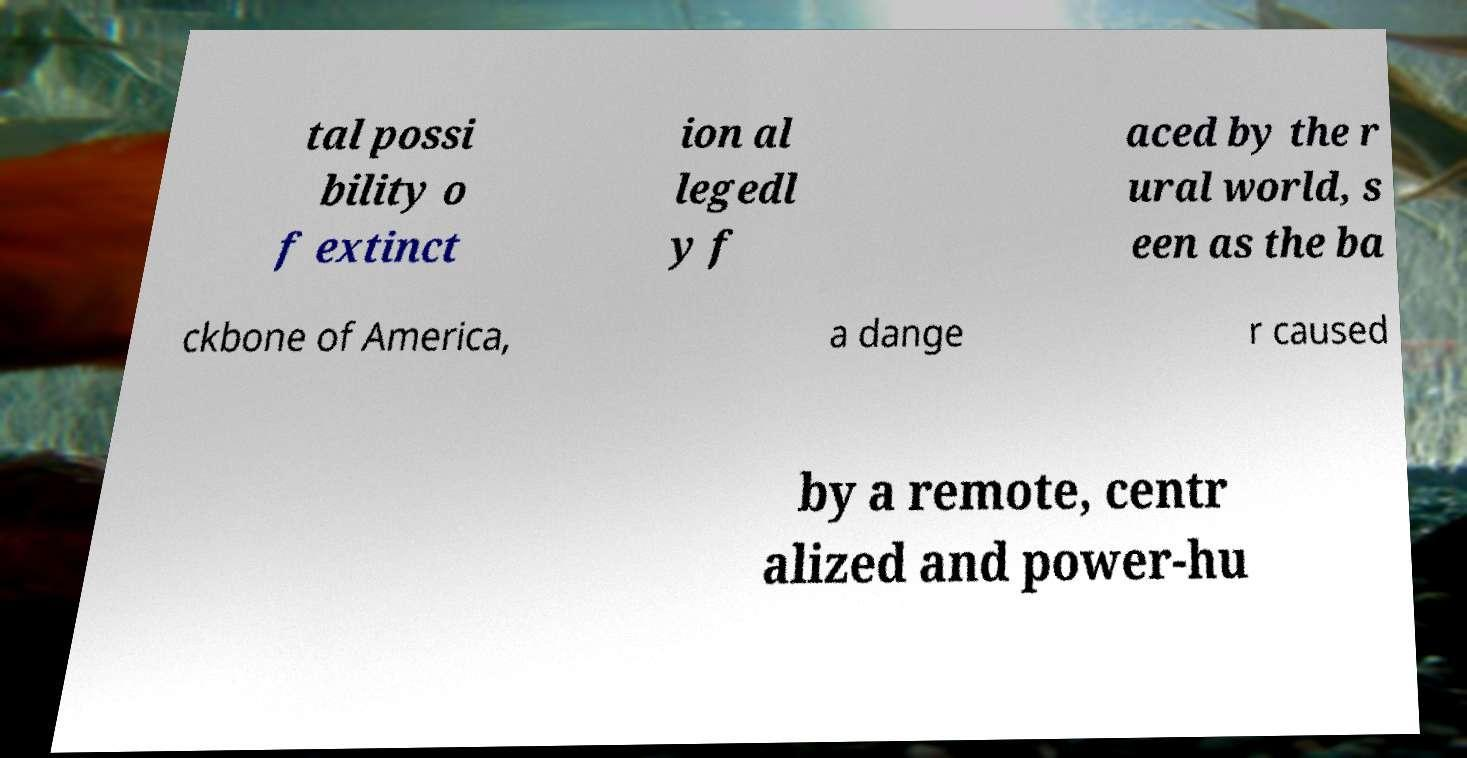Please identify and transcribe the text found in this image. tal possi bility o f extinct ion al legedl y f aced by the r ural world, s een as the ba ckbone of America, a dange r caused by a remote, centr alized and power-hu 